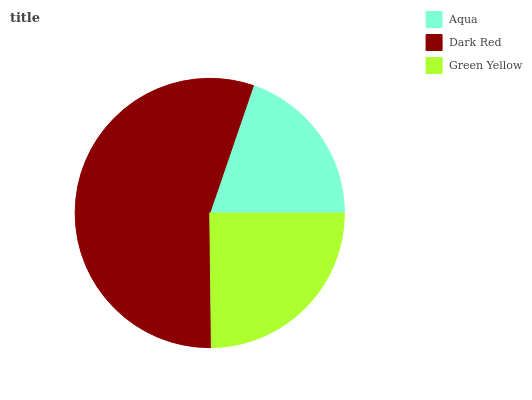Is Aqua the minimum?
Answer yes or no. Yes. Is Dark Red the maximum?
Answer yes or no. Yes. Is Green Yellow the minimum?
Answer yes or no. No. Is Green Yellow the maximum?
Answer yes or no. No. Is Dark Red greater than Green Yellow?
Answer yes or no. Yes. Is Green Yellow less than Dark Red?
Answer yes or no. Yes. Is Green Yellow greater than Dark Red?
Answer yes or no. No. Is Dark Red less than Green Yellow?
Answer yes or no. No. Is Green Yellow the high median?
Answer yes or no. Yes. Is Green Yellow the low median?
Answer yes or no. Yes. Is Dark Red the high median?
Answer yes or no. No. Is Aqua the low median?
Answer yes or no. No. 